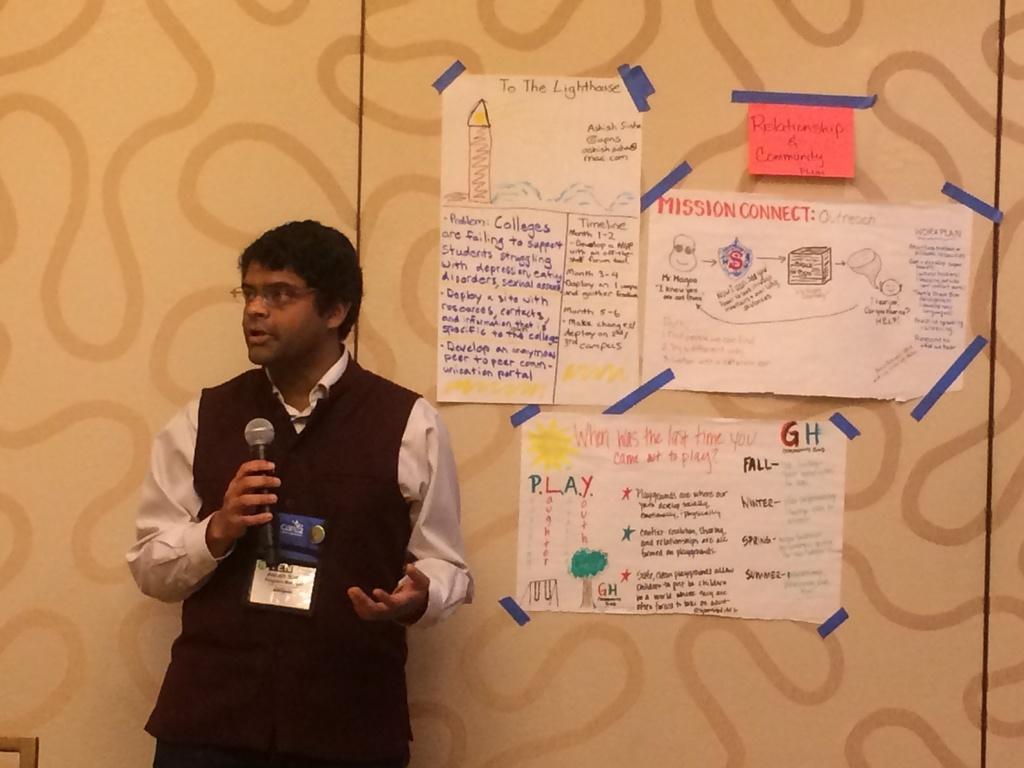Could you give a brief overview of what you see in this image? In this image there is a man standing. He is holding a microphone is his hand. There is an identity card to his shirt. Behind him there is a wall. On the wall there are charts stocked. On the charts there are images and text. 